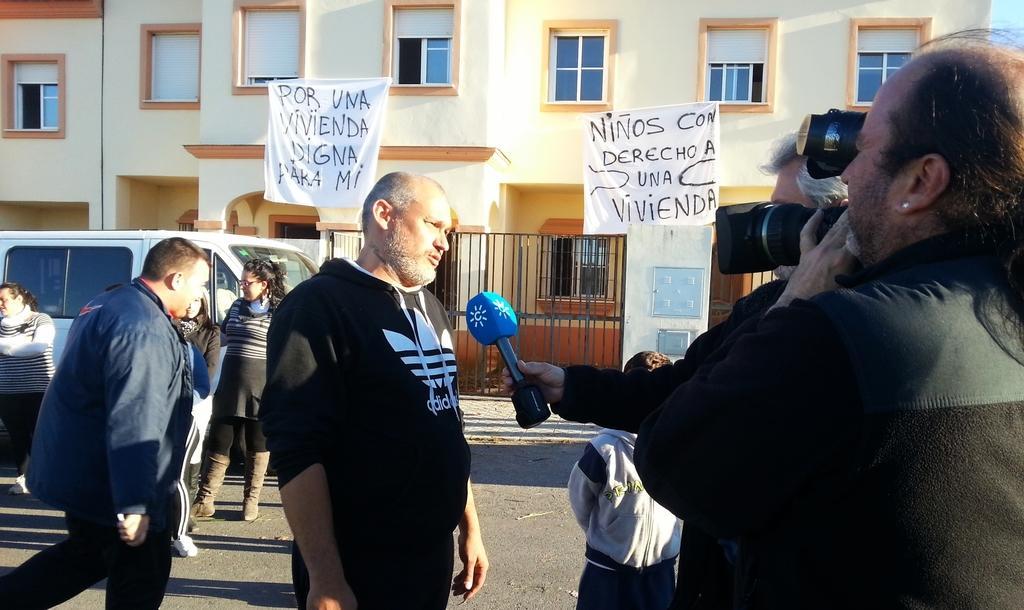How would you summarize this image in a sentence or two? As we can see in the image there are buildings, windows, banners, fence, group of people, car and mic. The person standing on the right side is wearing black color jacket and holding camera. 